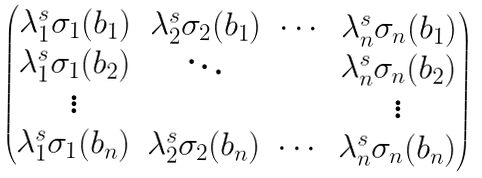Convert formula to latex. <formula><loc_0><loc_0><loc_500><loc_500>\begin{pmatrix} \lambda _ { 1 } ^ { s } \sigma _ { 1 } ( b _ { 1 } ) & \lambda _ { 2 } ^ { s } \sigma _ { 2 } ( b _ { 1 } ) & \cdots & \lambda _ { n } ^ { s } \sigma _ { n } ( b _ { 1 } ) \\ \lambda _ { 1 } ^ { s } \sigma _ { 1 } ( b _ { 2 } ) & \ddots & \ & \lambda _ { n } ^ { s } \sigma _ { n } ( b _ { 2 } ) \\ \vdots & & & \vdots \\ \lambda _ { 1 } ^ { s } \sigma _ { 1 } ( b _ { n } ) & \lambda _ { 2 } ^ { s } \sigma _ { 2 } ( b _ { n } ) & \cdots & \lambda _ { n } ^ { s } \sigma _ { n } ( b _ { n } ) \end{pmatrix}</formula> 